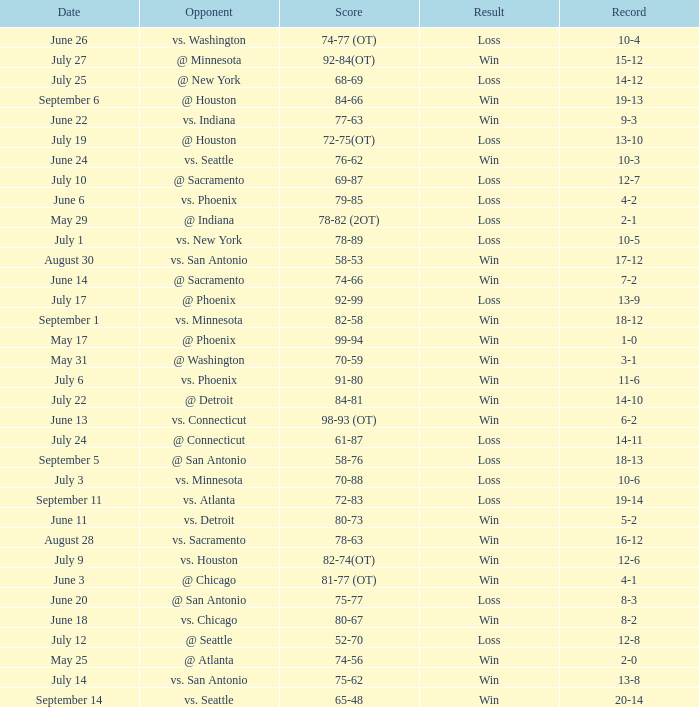What is the Record of the game with a Score of 65-48? 20-14. 